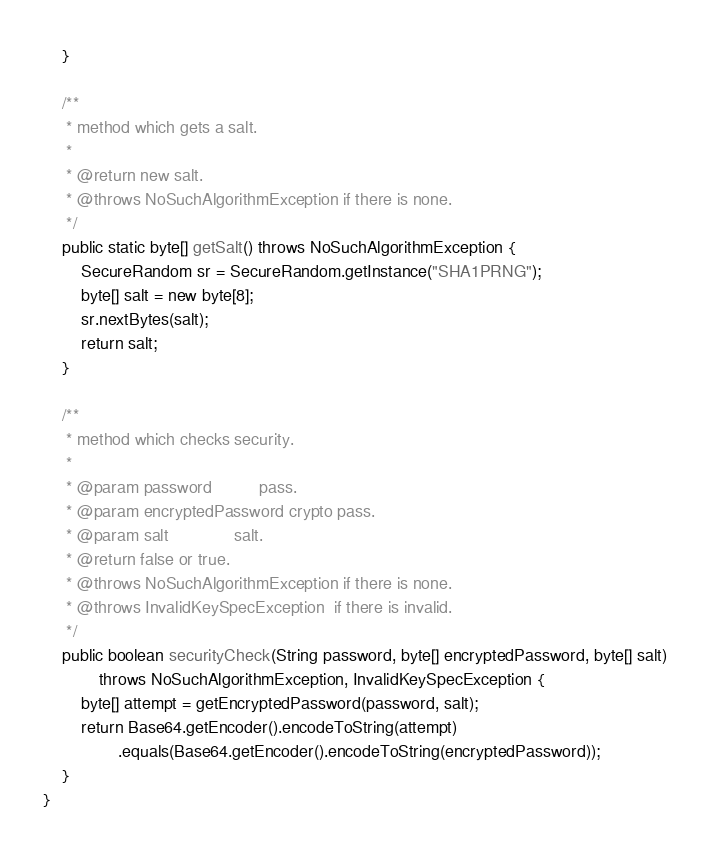<code> <loc_0><loc_0><loc_500><loc_500><_Java_>    }

    /**
     * method which gets a salt.
     *
     * @return new salt.
     * @throws NoSuchAlgorithmException if there is none.
     */
    public static byte[] getSalt() throws NoSuchAlgorithmException {
        SecureRandom sr = SecureRandom.getInstance("SHA1PRNG");
        byte[] salt = new byte[8];
        sr.nextBytes(salt);
        return salt;
    }

    /**
     * method which checks security.
     *
     * @param password          pass.
     * @param encryptedPassword crypto pass.
     * @param salt              salt.
     * @return false or true.
     * @throws NoSuchAlgorithmException if there is none.
     * @throws InvalidKeySpecException  if there is invalid.
     */
    public boolean securityCheck(String password, byte[] encryptedPassword, byte[] salt)
            throws NoSuchAlgorithmException, InvalidKeySpecException {
        byte[] attempt = getEncryptedPassword(password, salt);
        return Base64.getEncoder().encodeToString(attempt)
                .equals(Base64.getEncoder().encodeToString(encryptedPassword));
    }
}
</code> 